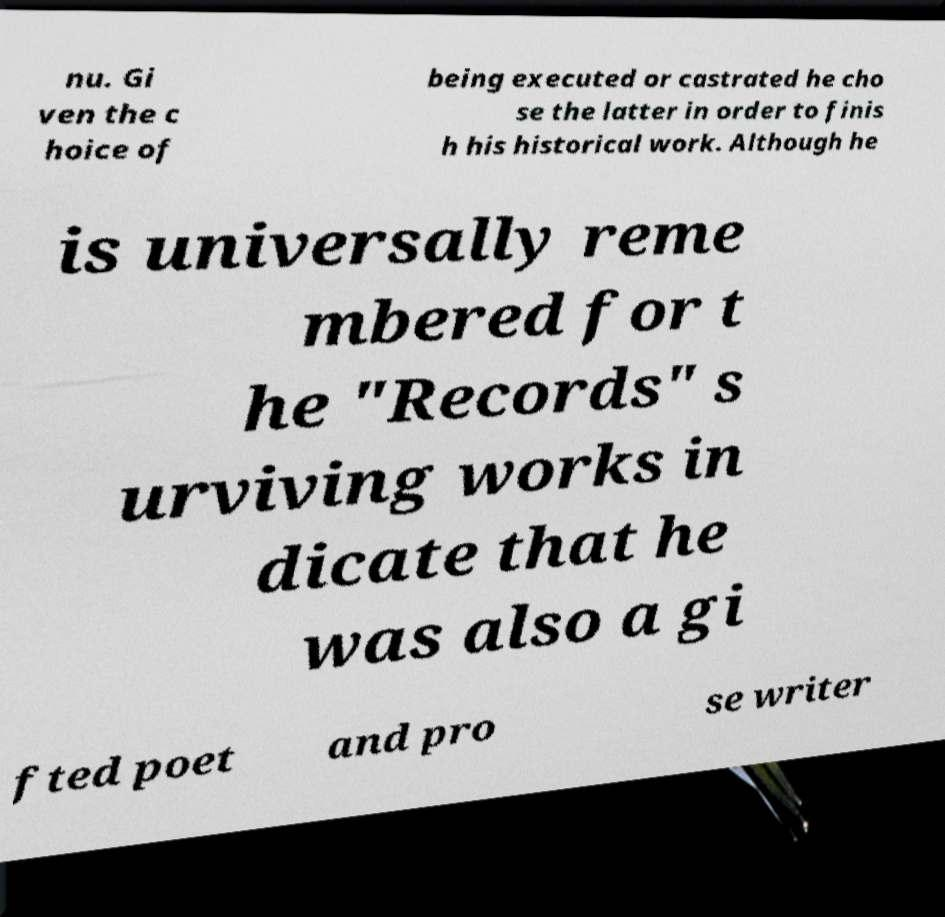Please read and relay the text visible in this image. What does it say? nu. Gi ven the c hoice of being executed or castrated he cho se the latter in order to finis h his historical work. Although he is universally reme mbered for t he "Records" s urviving works in dicate that he was also a gi fted poet and pro se writer 